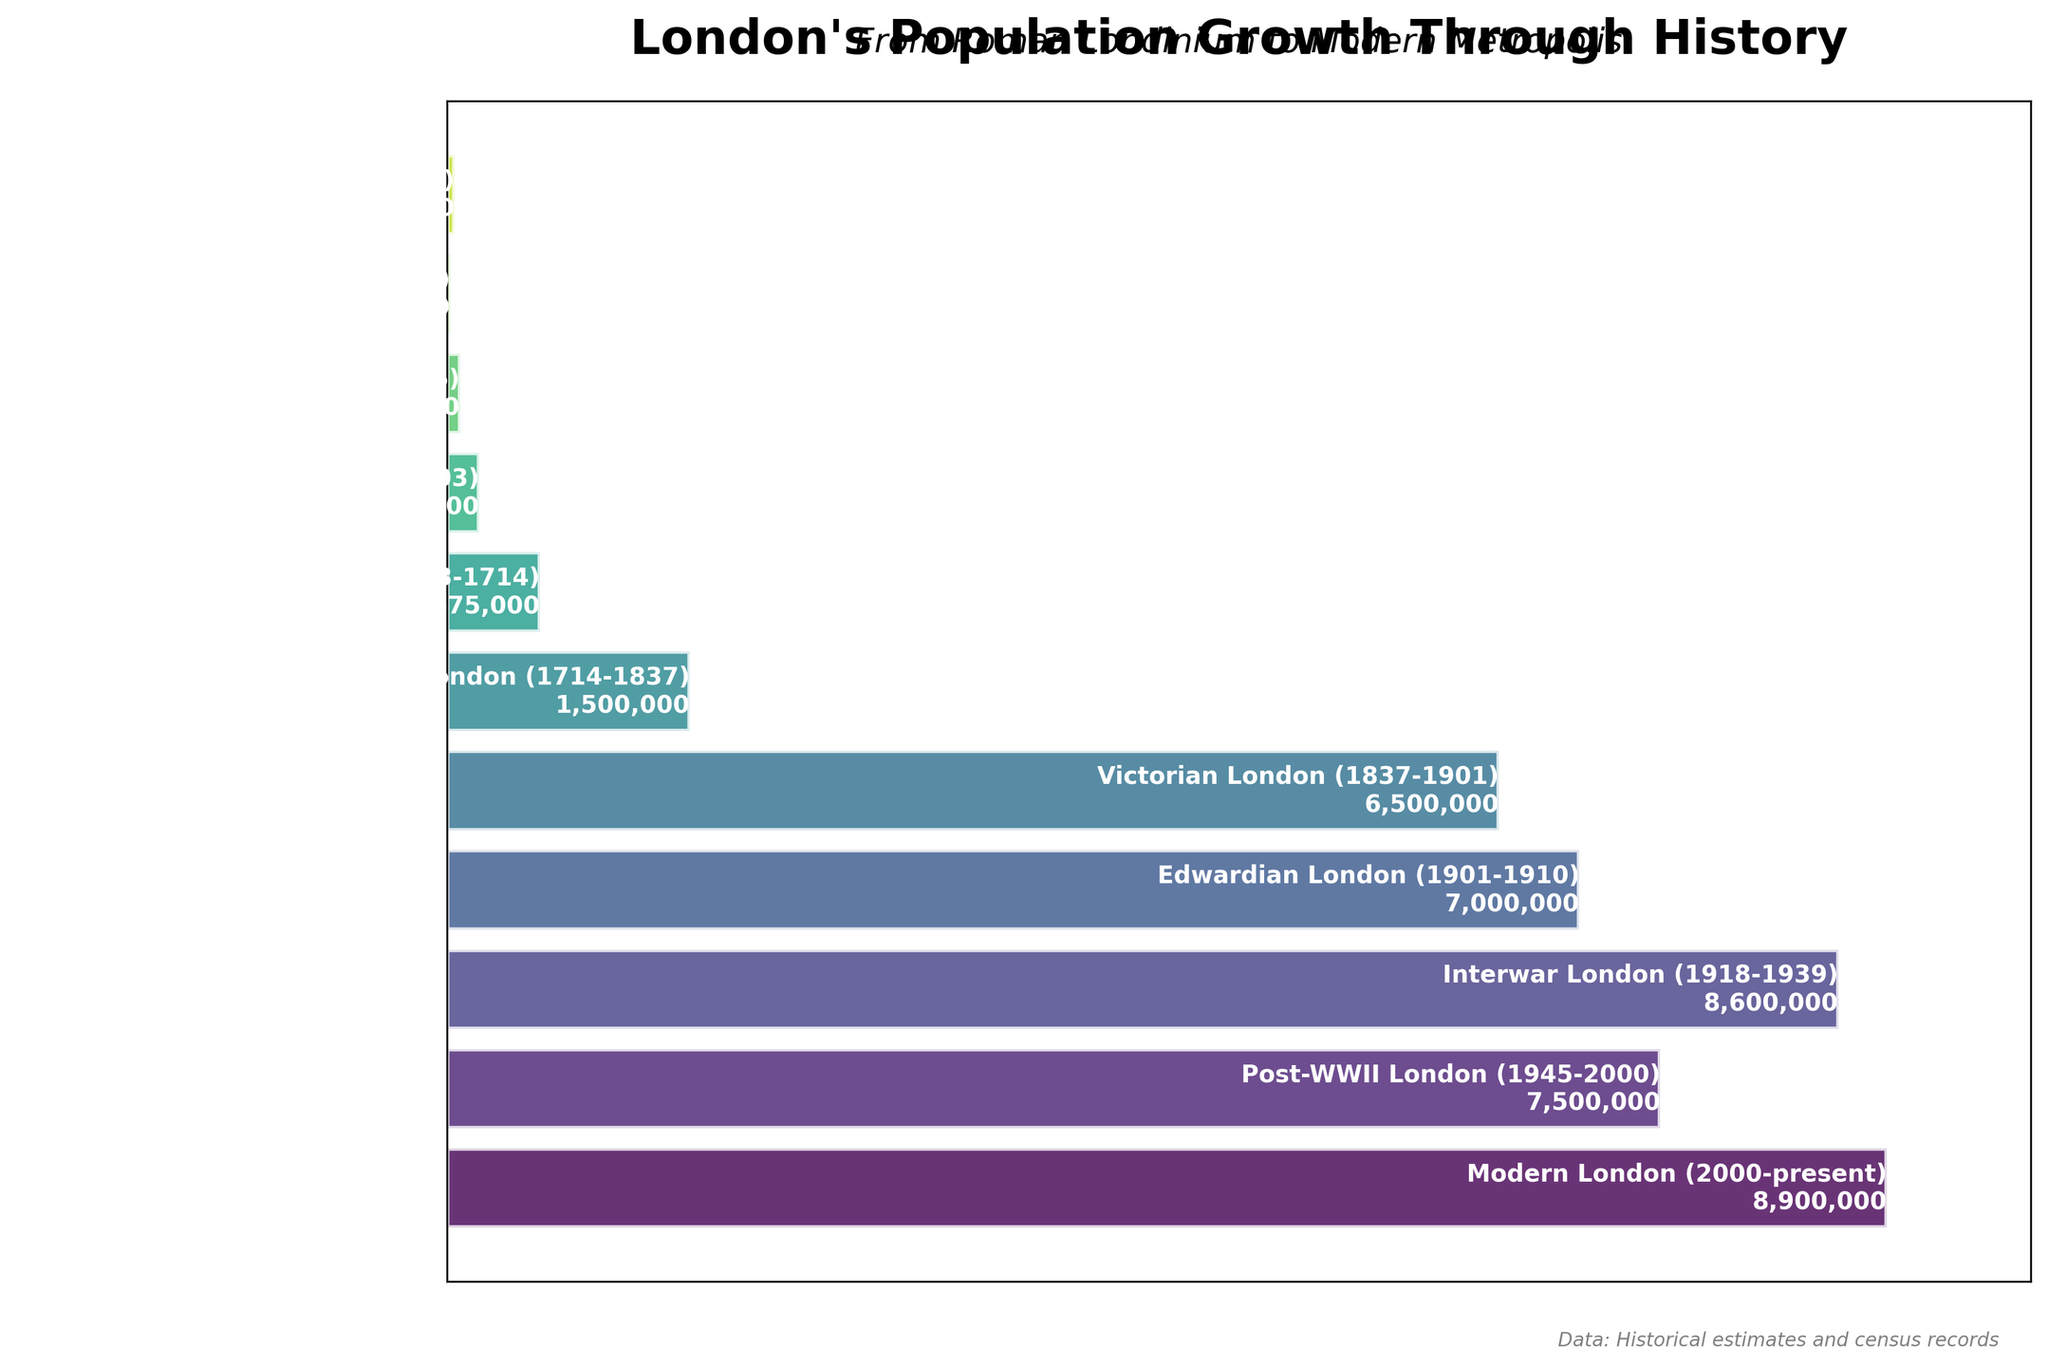How many periods are shown in the funnel chart? To determine the number of periods, count the distinct rows or bars represented in the funnel chart.
Answer: 11 Which period had the smallest population and what was that population? Look for the bar representing the smallest width in the funnel chart and read the period and population label next to it.
Answer: Anglo-Saxon London (410-1066), 20,000 During which period did London's population first exceed one million? Identify the period where the population label first exceeds 1,000,000 on the funnel chart.
Answer: Georgian London (1714-1837) What is the difference in population between Victorian London and Modern London? Subtract the population of Victorian London from the population of Modern London. 8,900,000 - 6,500,000 = 2,400,000.
Answer: 2,400,000 Which period saw the largest increase in population from its previous period and what was the increase? Calculate the difference in population between consecutive periods and find the largest difference. For example, the increase from Tudor London to Stuart London is 575,000 - 200,000 = 375,000. Continue this for all periods to determine the largest increase.
Answer: Victorian London (1837-1901), 5,000,000 Which period had a smaller population: Medieval London or Tudor London? Compare the population labels for Medieval London and Tudor London on the funnel chart.
Answer: Medieval London What does the title of the funnel chart indicate? Read the main title text displayed at the top of the chart.
Answer: London's Population Growth Through History What periods had populations between 8,000,000 and 9,000,000? Identify bars with population labels within the range of 8,000,000 and 9,000,000 on the chart.
Answer: Interwar London (1918-1939), Modern London (2000-present) How much did the population change between Interwar London and Post-WWII London? Subtract the population of Post-WWII London from the population of Interwar London. 8,600,000 - 7,500,000 = 1,100,000.
Answer: 1,100,000 Which period is directly opposite Georgian London on the chart? On a funnel chart, periods are listed either from the top or the bottom. Assuming a reverse chronological order, find the period at the corresponding position on the other end of the chart from Georgian London.
Answer: Roman Londinium (43-410 AD) 